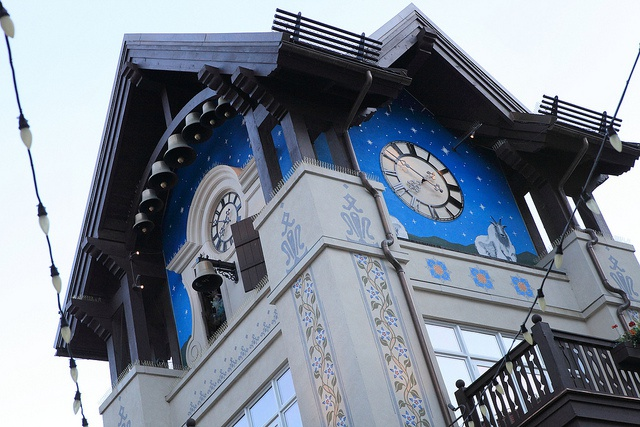Describe the objects in this image and their specific colors. I can see clock in lightblue, darkgray, gray, and black tones and clock in lightblue, darkgray, gray, and black tones in this image. 